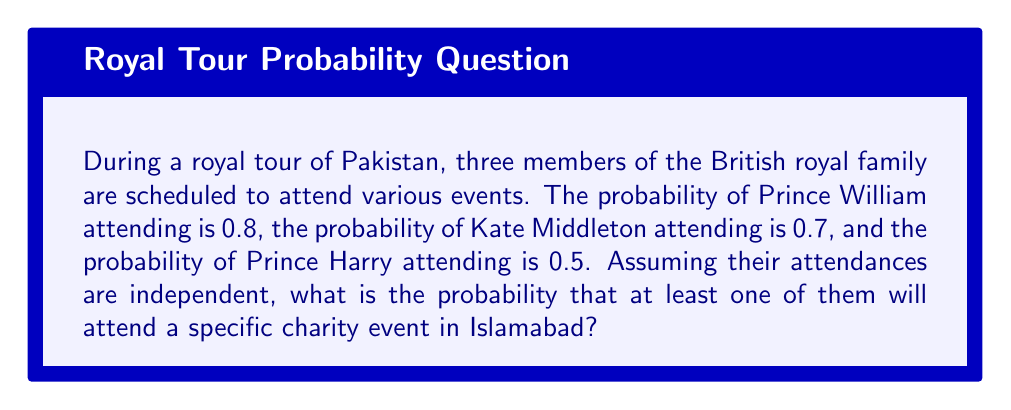Can you answer this question? Let's approach this step-by-step:

1) First, we need to find the probability that none of them attend. We can do this by multiplying the probabilities of each royal not attending:

   P(none attend) = P(William doesn't) × P(Kate doesn't) × P(Harry doesn't)
   
   $P(\text{none}) = (1-0.8) \times (1-0.7) \times (1-0.5)$

2) Let's calculate this:
   
   $P(\text{none}) = 0.2 \times 0.3 \times 0.5 = 0.03$

3) Now, the probability that at least one attends is the opposite of none attending:

   $P(\text{at least one}) = 1 - P(\text{none})$

4) Let's calculate the final probability:

   $P(\text{at least one}) = 1 - 0.03 = 0.97$

5) Therefore, the probability that at least one of them will attend the charity event in Islamabad is 0.97 or 97%.
Answer: 0.97 